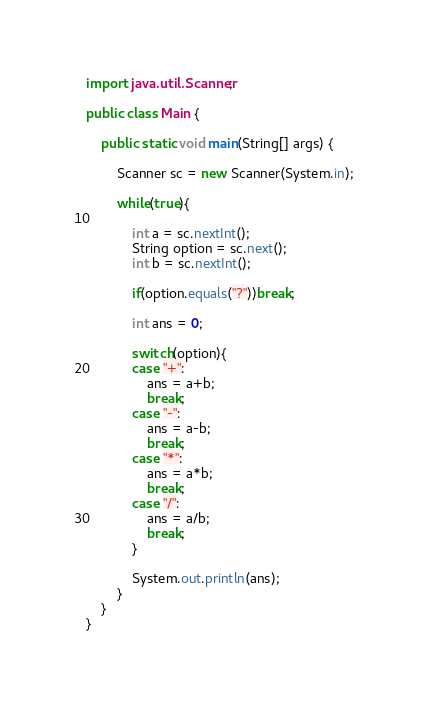Convert code to text. <code><loc_0><loc_0><loc_500><loc_500><_Java_>import java.util.Scanner;

public class Main {

	public static void main(String[] args) {

		Scanner sc = new Scanner(System.in);

		while(true){

			int a = sc.nextInt();
			String option = sc.next();
			int b = sc.nextInt();

			if(option.equals("?"))break;

			int ans = 0;

			switch(option){
			case "+":
				ans = a+b;
				break;
			case "-":
				ans = a-b;
				break;
			case "*":
				ans = a*b;
				break;
			case "/":
				ans = a/b;
				break;
			}

			System.out.println(ans);
		}
	}
}

</code> 